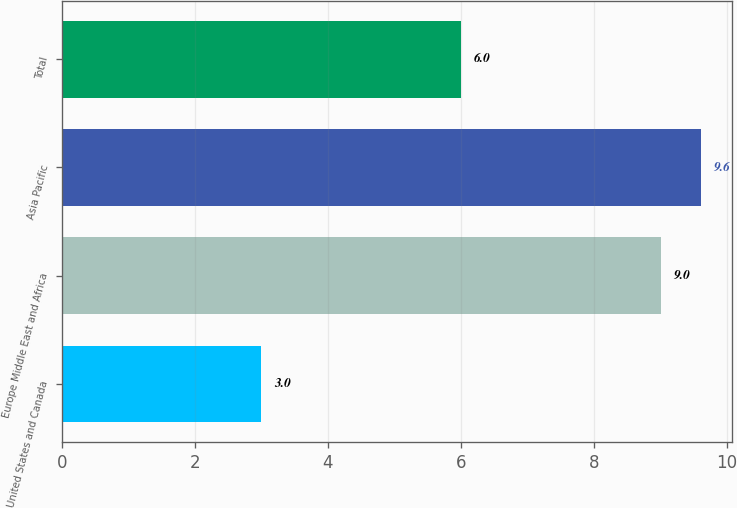<chart> <loc_0><loc_0><loc_500><loc_500><bar_chart><fcel>United States and Canada<fcel>Europe Middle East and Africa<fcel>Asia Pacific<fcel>Total<nl><fcel>3<fcel>9<fcel>9.6<fcel>6<nl></chart> 